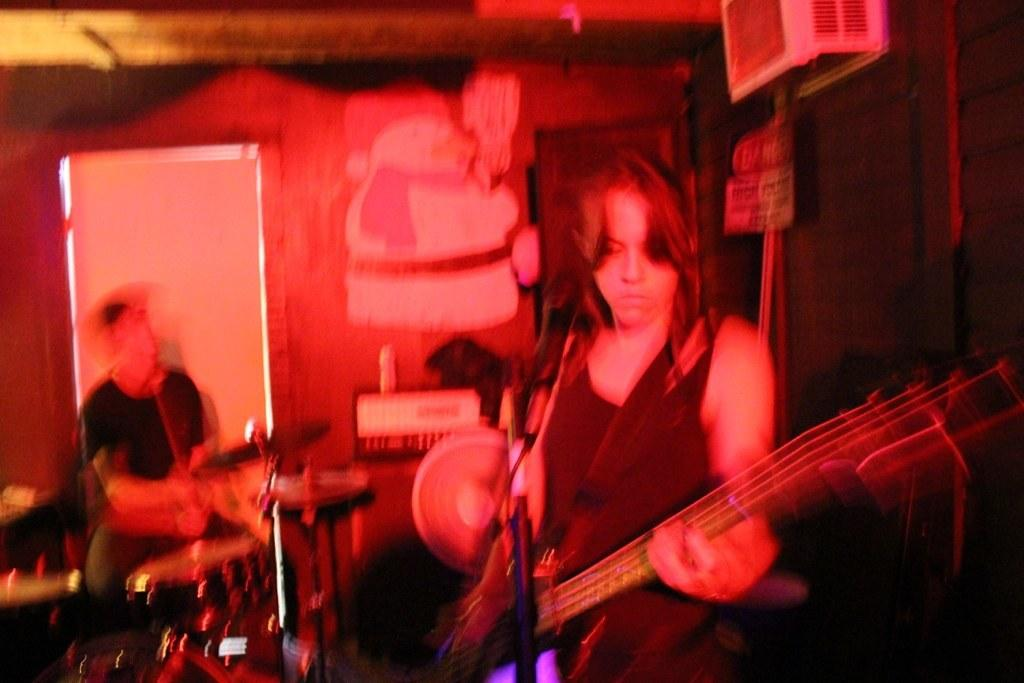Who is the main subject in the image? There is a girl in the image. What is the girl doing in the image? The girl is playing a guitar. What object is in front of the girl? There is a microphone in front of the girl. How many stars can be seen in the image? There are no stars visible in the image. What does the girl need to play the guitar in the image? The girl is already playing the guitar in the image, so she does not need anything specific to play it. 